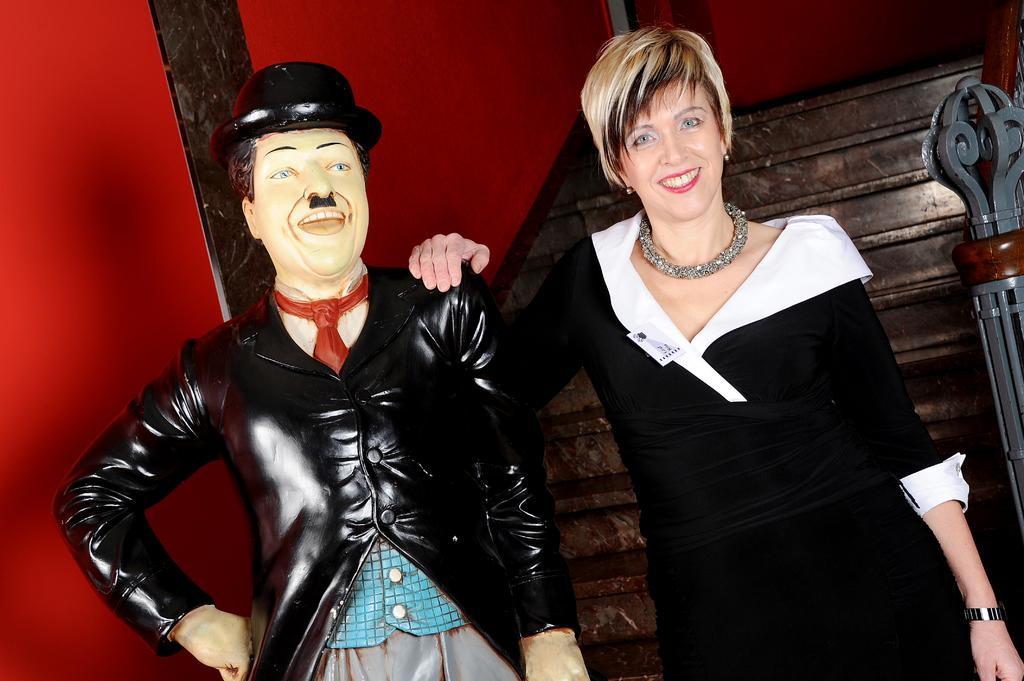Please provide a concise description of this image. On the right there is a woman in black dress. On the right it is mannequin. At the top left it is wall painted red. In the center there is staircase. On the right it is hand railing. 